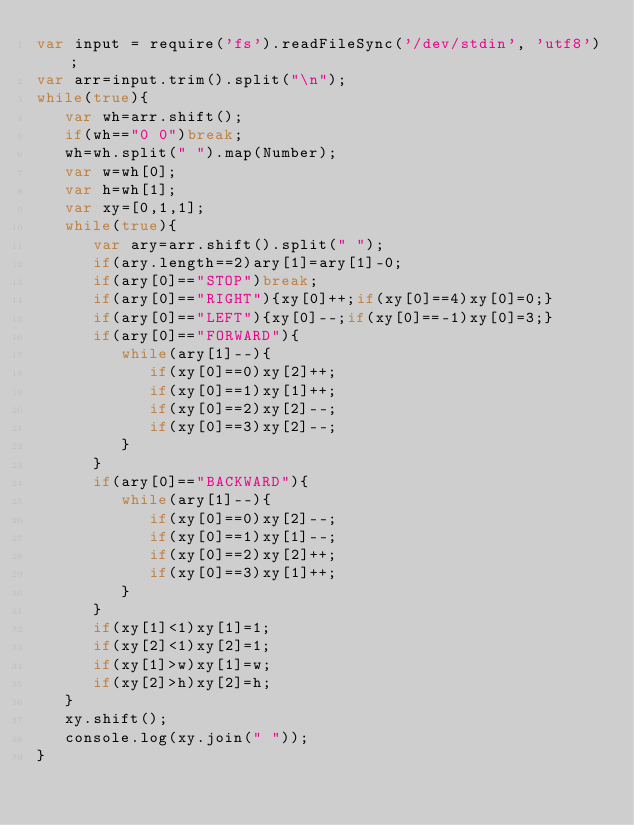Convert code to text. <code><loc_0><loc_0><loc_500><loc_500><_JavaScript_>var input = require('fs').readFileSync('/dev/stdin', 'utf8');
var arr=input.trim().split("\n");
while(true){
   var wh=arr.shift();
   if(wh=="0 0")break;
   wh=wh.split(" ").map(Number);
   var w=wh[0];
   var h=wh[1];
   var xy=[0,1,1];
   while(true){
      var ary=arr.shift().split(" ");
      if(ary.length==2)ary[1]=ary[1]-0;
      if(ary[0]=="STOP")break;
      if(ary[0]=="RIGHT"){xy[0]++;if(xy[0]==4)xy[0]=0;}
      if(ary[0]=="LEFT"){xy[0]--;if(xy[0]==-1)xy[0]=3;}
      if(ary[0]=="FORWARD"){
         while(ary[1]--){
            if(xy[0]==0)xy[2]++;
            if(xy[0]==1)xy[1]++;
            if(xy[0]==2)xy[2]--;
            if(xy[0]==3)xy[2]--;
         }
      }
      if(ary[0]=="BACKWARD"){
         while(ary[1]--){
            if(xy[0]==0)xy[2]--;
            if(xy[0]==1)xy[1]--;
            if(xy[0]==2)xy[2]++;
            if(xy[0]==3)xy[1]++;
         }
      }
      if(xy[1]<1)xy[1]=1;
      if(xy[2]<1)xy[2]=1;
      if(xy[1]>w)xy[1]=w;
      if(xy[2]>h)xy[2]=h;
   }
   xy.shift();
   console.log(xy.join(" "));
}</code> 